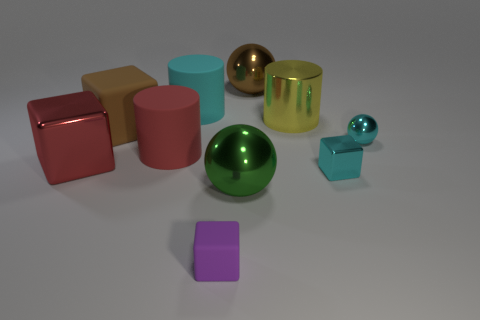Are there any green objects?
Your answer should be compact. Yes. Are there fewer brown shiny balls that are in front of the large red matte cylinder than big red metallic objects that are left of the big green ball?
Make the answer very short. Yes. There is a large object that is on the left side of the big brown matte block; what is its shape?
Provide a succinct answer. Cube. Do the tiny cyan ball and the tiny cyan block have the same material?
Offer a terse response. Yes. Is there anything else that is the same material as the purple object?
Your answer should be very brief. Yes. There is a large red thing that is the same shape as the brown matte thing; what is its material?
Ensure brevity in your answer.  Metal. Are there fewer brown objects on the left side of the large brown metal ball than small metal balls?
Your response must be concise. No. What number of large green things are to the right of the tiny cyan metallic cube?
Keep it short and to the point. 0. Do the tiny thing left of the brown ball and the brown object that is right of the small purple rubber object have the same shape?
Keep it short and to the point. No. The matte thing that is both behind the cyan block and in front of the large rubber cube has what shape?
Give a very brief answer. Cylinder. 